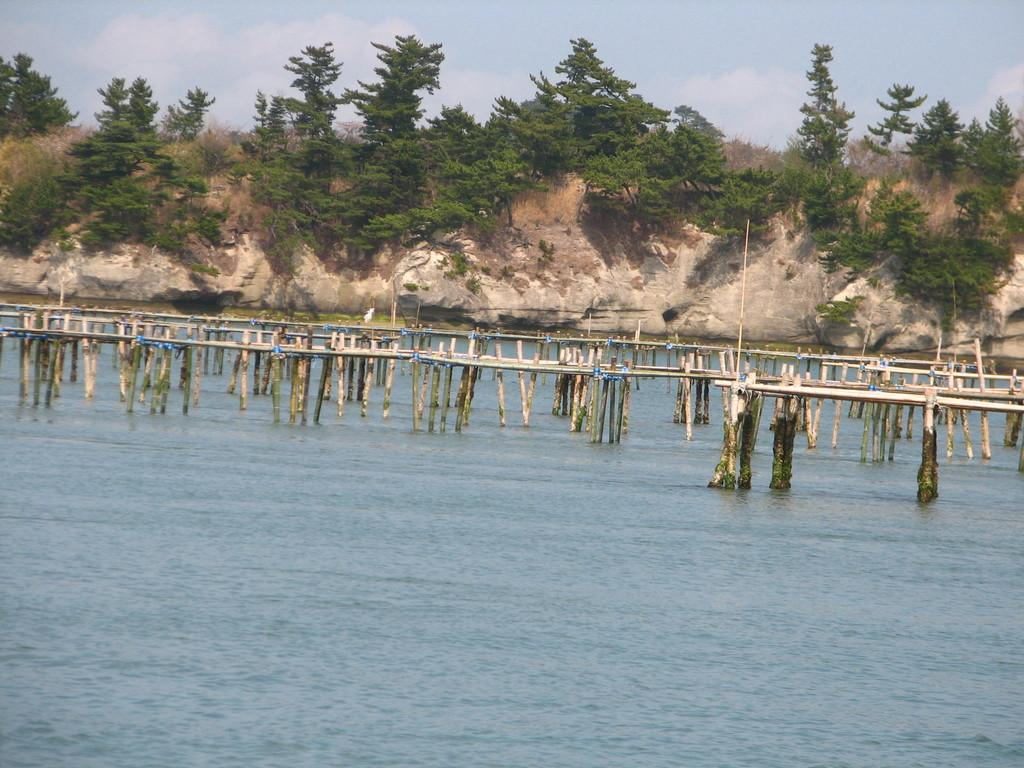What can be seen in the water in the image? There are poles in the water. What is visible in the background of the image? There are trees and plants on a cliff in the background. What is present in the sky in the image? There are clouds in the sky. What type of oil can be seen floating on the water in the image? There is no oil present in the image; it only shows poles in the water. How does the comfort of the trees in the background affect the overall mood of the image? The image does not convey any information about the comfort of the trees or the overall mood, as it only shows trees in the background. 